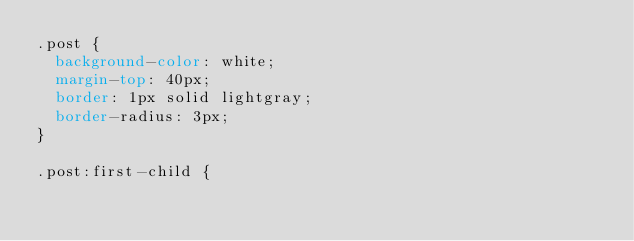Convert code to text. <code><loc_0><loc_0><loc_500><loc_500><_CSS_>.post {
  background-color: white;
  margin-top: 40px;
  border: 1px solid lightgray;
  border-radius: 3px;
}

.post:first-child {</code> 